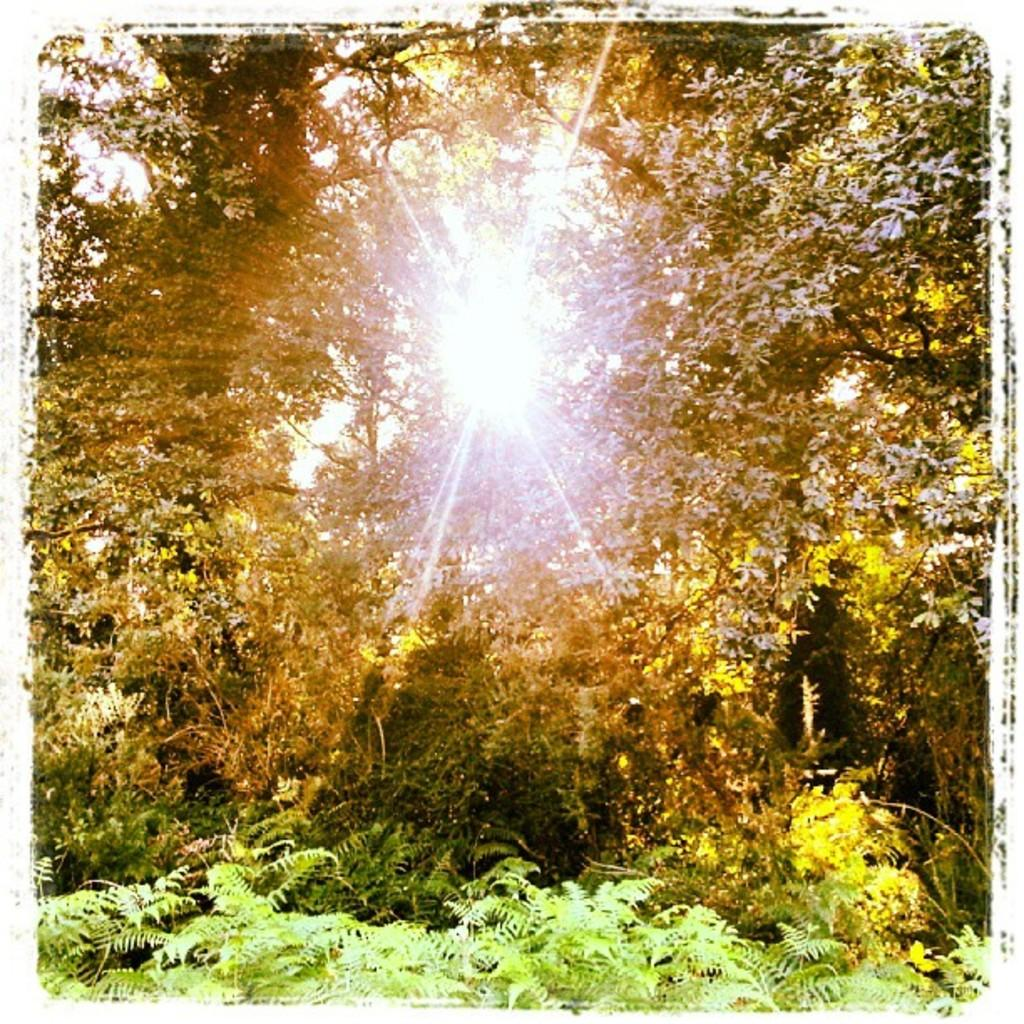What can be said about the nature of the image? The image is edited. What type of natural elements can be seen in the image? There are plants and trees in the image. What is visible in the background of the image? The sky is visible in the background of the image. How many bikes are visible in the image? There are no bikes present in the image. Is there a veil covering any of the plants in the image? There is no veil present in the image. What type of utensil can be seen in the image? There is no utensil, such as a spoon, present in the image. 